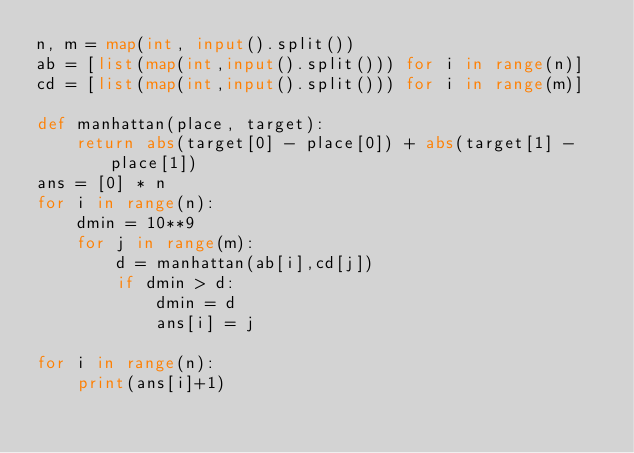<code> <loc_0><loc_0><loc_500><loc_500><_Python_>n, m = map(int, input().split())
ab = [list(map(int,input().split())) for i in range(n)]
cd = [list(map(int,input().split())) for i in range(m)]

def manhattan(place, target):
	return abs(target[0] - place[0]) + abs(target[1] - place[1])
ans = [0] * n
for i in range(n):
	dmin = 10**9
	for j in range(m):
		d = manhattan(ab[i],cd[j])
		if dmin > d:
			dmin = d
			ans[i] = j

for i in range(n):
	print(ans[i]+1)

</code> 